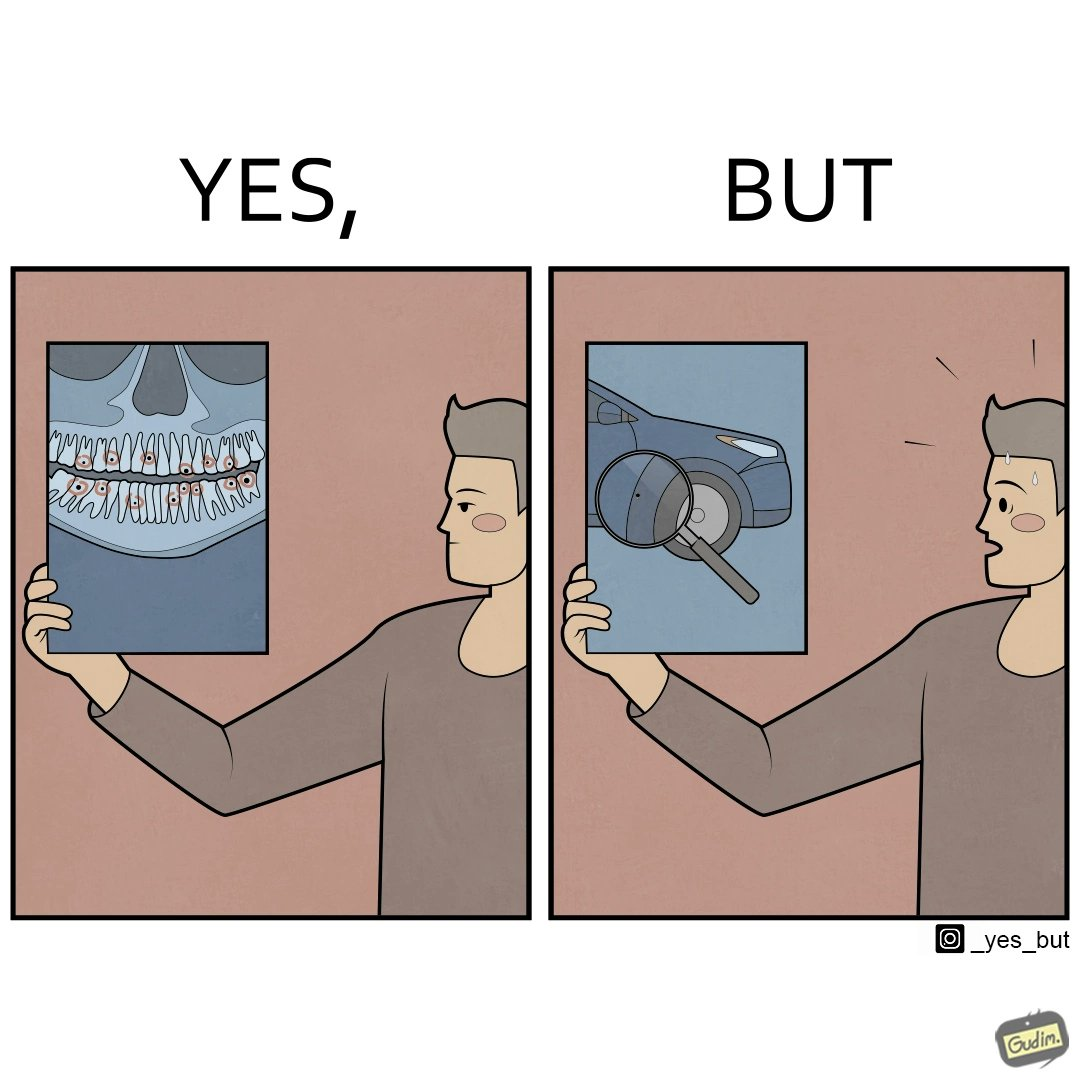Would you classify this image as satirical? Yes, this image is satirical. 